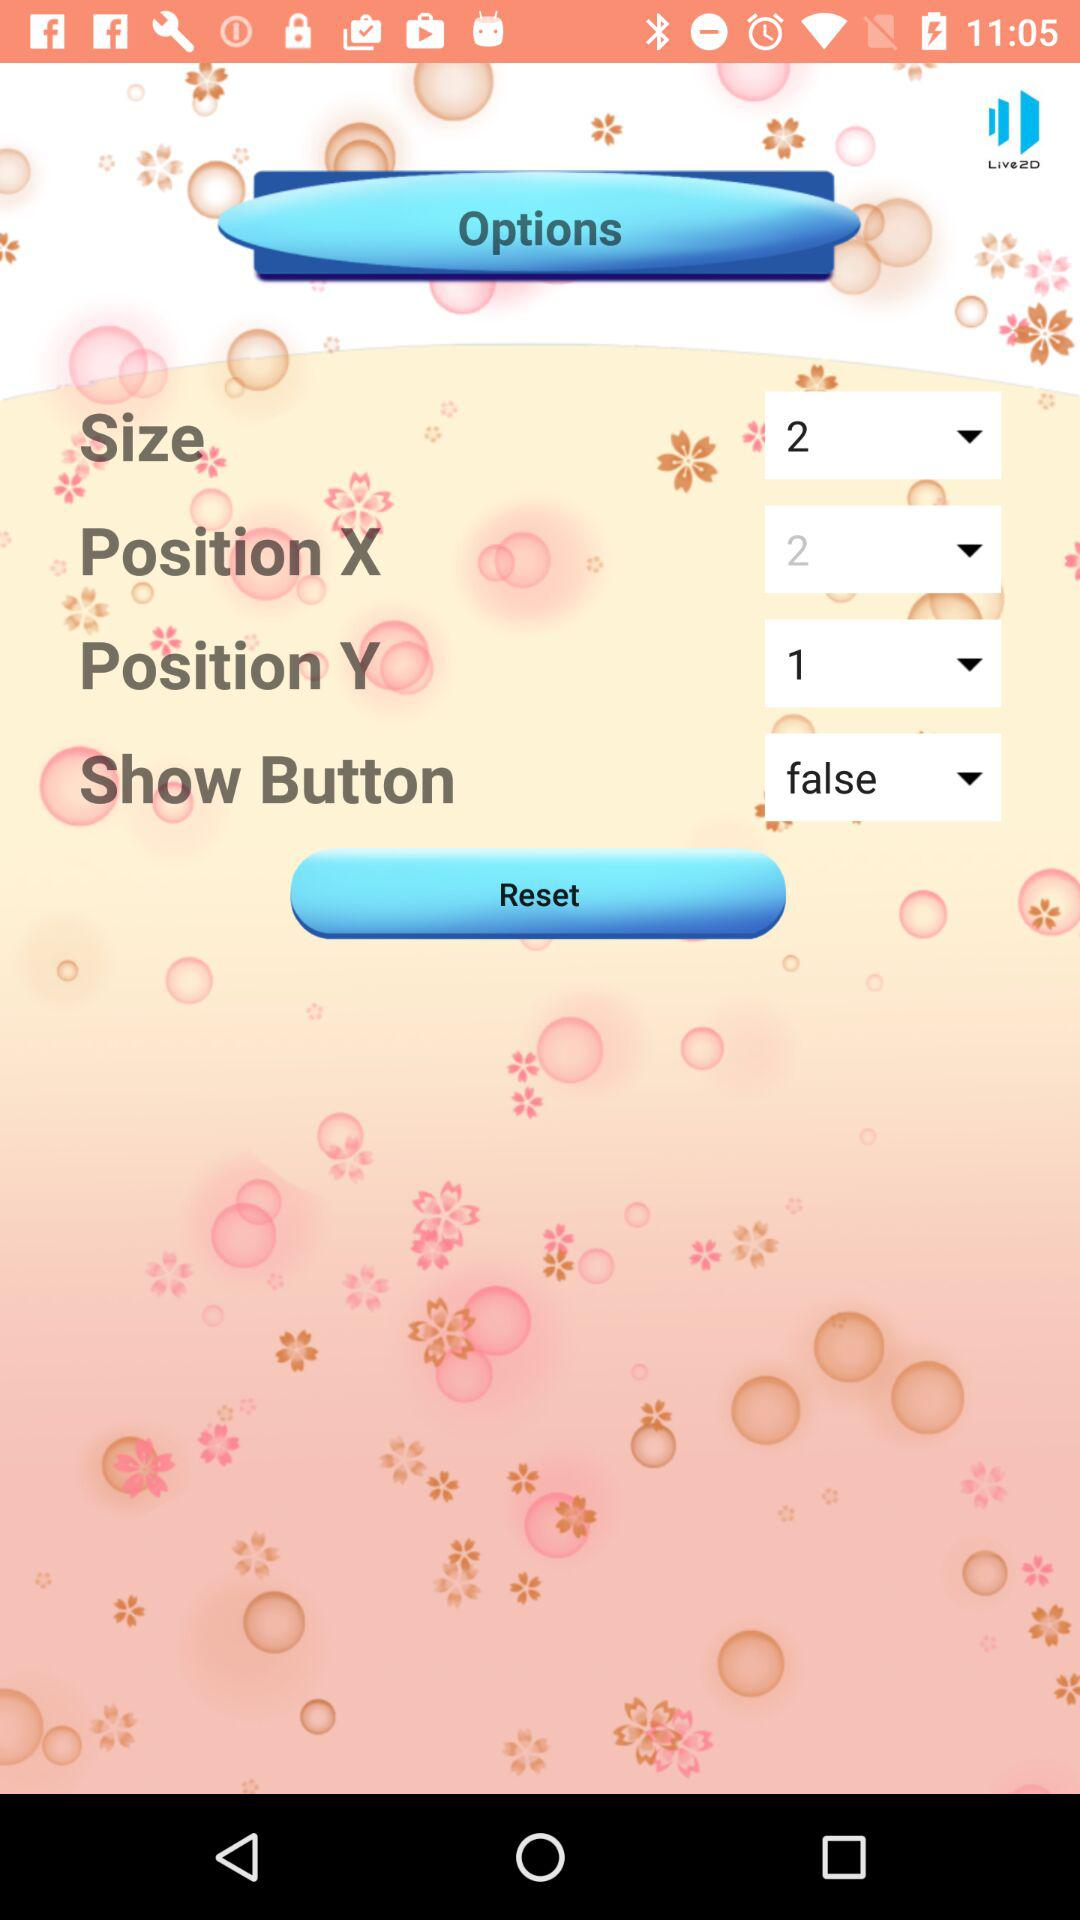Which is the selected option for the "Show Button"? The selected option for the "Show Button" is "false". 